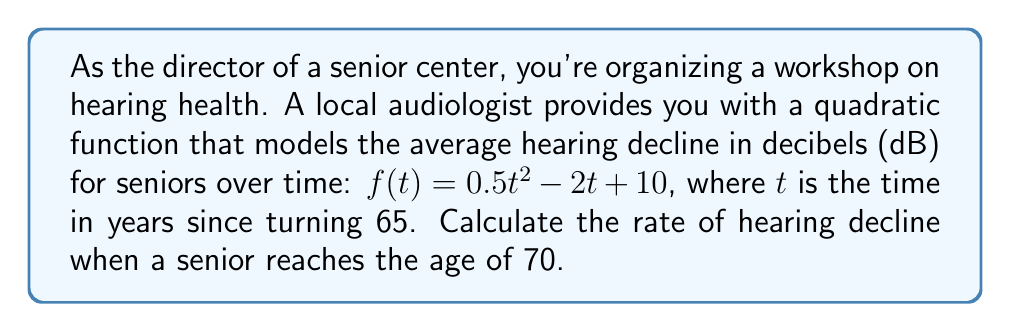Show me your answer to this math problem. To solve this problem, we need to follow these steps:

1) The function given is $f(t) = 0.5t^2 - 2t + 10$, where $f(t)$ represents the hearing decline in dB and $t$ is the time in years since turning 65.

2) We need to find the rate of change at $t = 5$ (since 70 is 5 years after 65).

3) The rate of change is given by the derivative of the function. Let's call this $f'(t)$.

4) To find $f'(t)$, we use the power rule and the constant rule of differentiation:
   
   $f'(t) = (0.5t^2)' + (-2t)' + 10'$
   $f'(t) = 0.5 \cdot 2t + (-2) + 0$
   $f'(t) = t - 2$

5) Now we need to evaluate $f'(5)$:
   
   $f'(5) = 5 - 2 = 3$

Therefore, at age 70 (5 years after 65), the rate of hearing decline is 3 dB per year.
Answer: 3 dB per year 